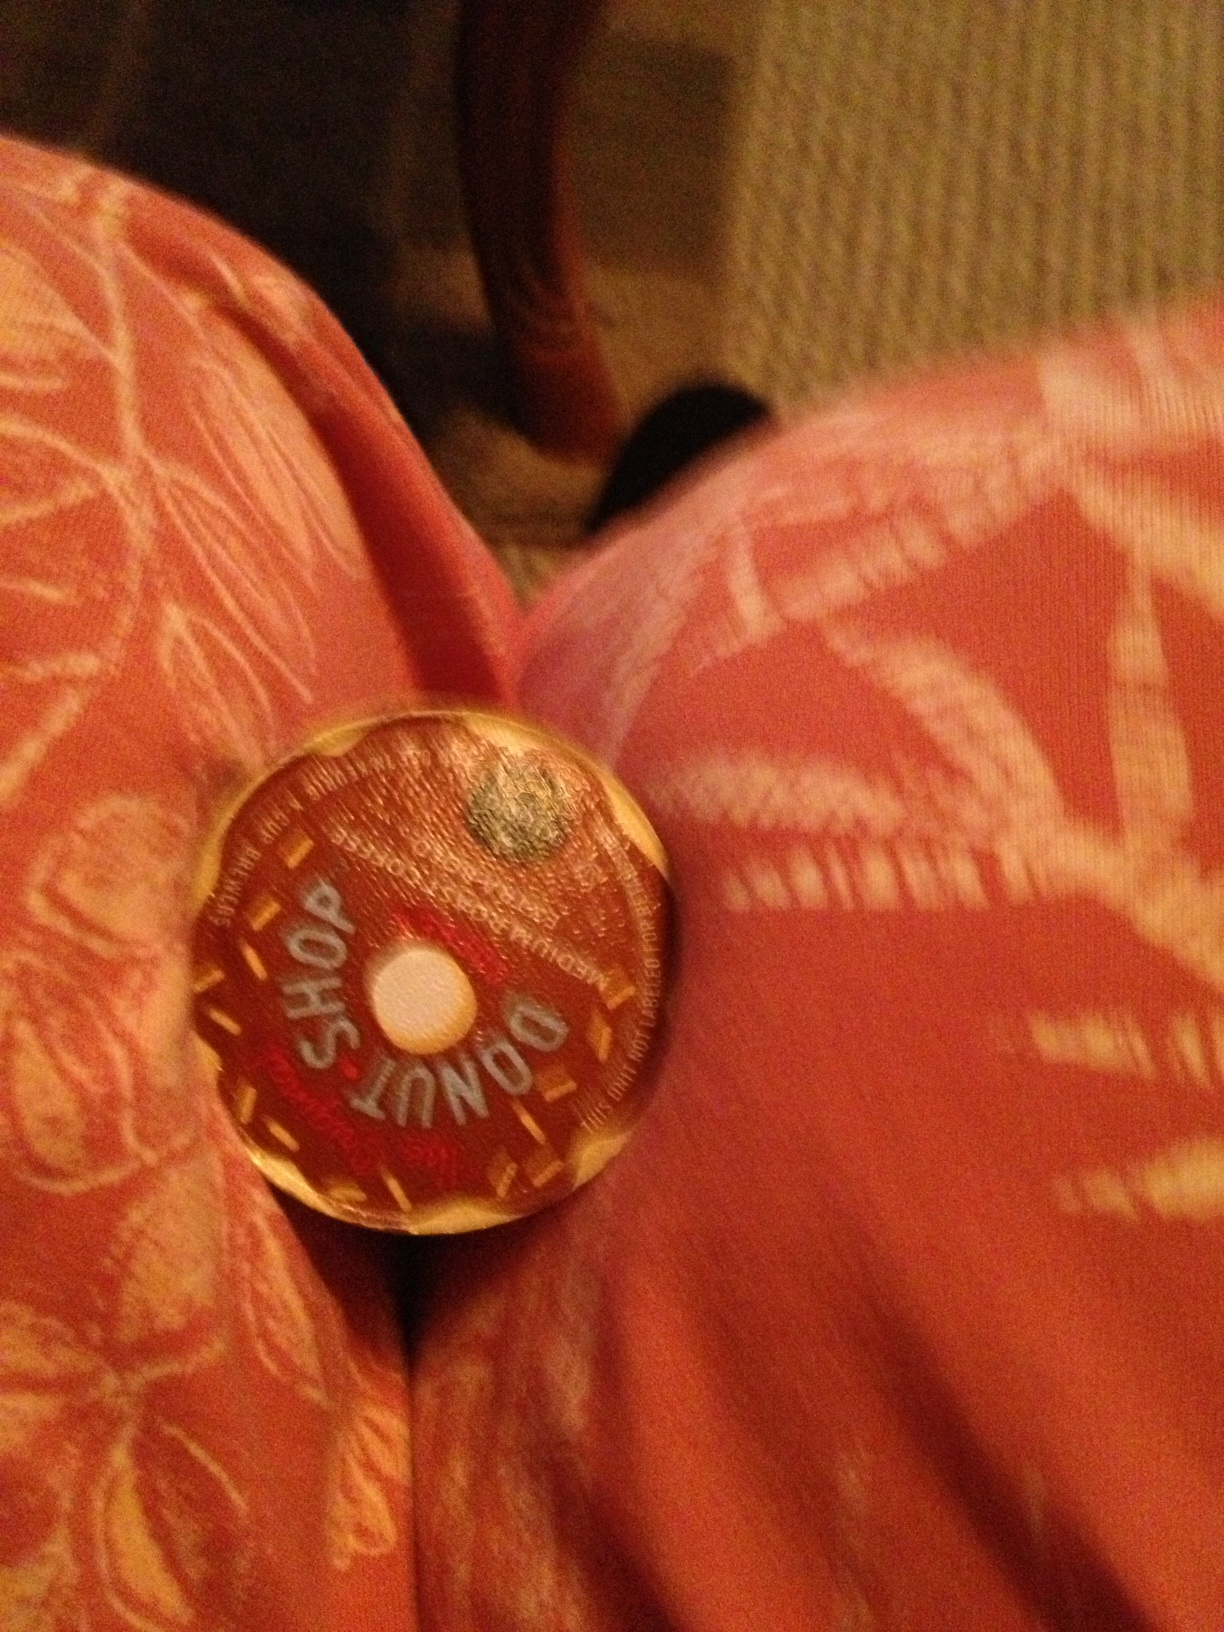What other flavors does this brand offer? The Donut Shop brand typically offers a variety of flavors, including Original, Dark, Decaf, and flavored options like Vanilla Cream Puff and Coconut Mocha. They are known for their sweet, comforting taste that pairs well with actual donuts! 